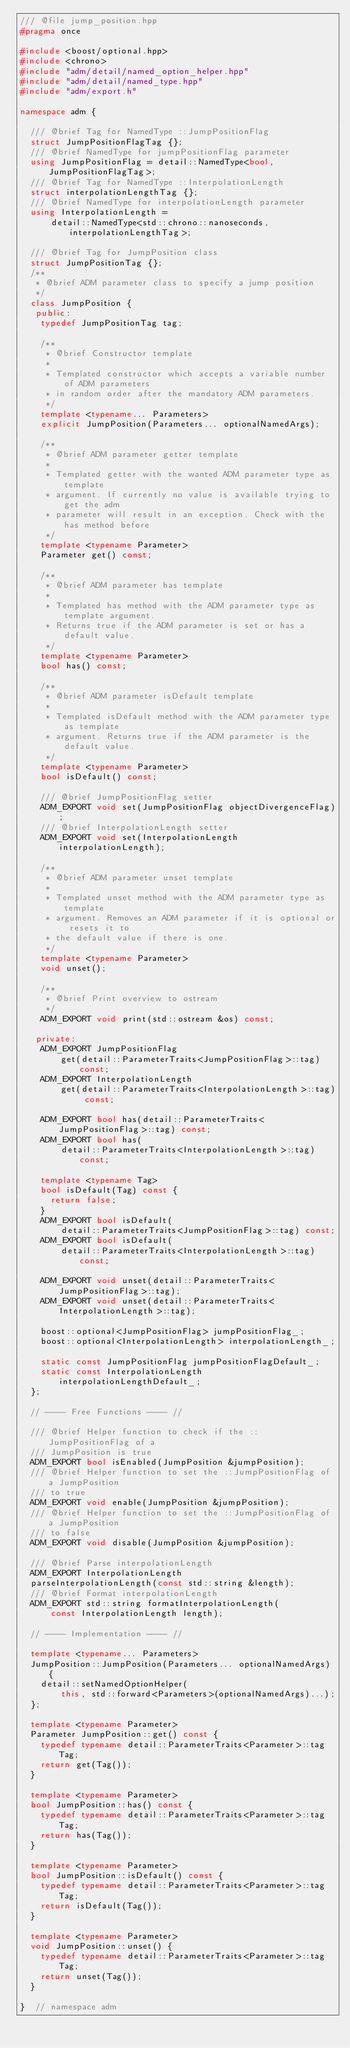Convert code to text. <code><loc_0><loc_0><loc_500><loc_500><_C++_>/// @file jump_position.hpp
#pragma once

#include <boost/optional.hpp>
#include <chrono>
#include "adm/detail/named_option_helper.hpp"
#include "adm/detail/named_type.hpp"
#include "adm/export.h"

namespace adm {

  /// @brief Tag for NamedType ::JumpPositionFlag
  struct JumpPositionFlagTag {};
  /// @brief NamedType for jumpPositionFlag parameter
  using JumpPositionFlag = detail::NamedType<bool, JumpPositionFlagTag>;
  /// @brief Tag for NamedType ::InterpolationLength
  struct interpolationLengthTag {};
  /// @brief NamedType for interpolationLength parameter
  using InterpolationLength =
      detail::NamedType<std::chrono::nanoseconds, interpolationLengthTag>;

  /// @brief Tag for JumpPosition class
  struct JumpPositionTag {};
  /**
   * @brief ADM parameter class to specify a jump position
   */
  class JumpPosition {
   public:
    typedef JumpPositionTag tag;

    /**
     * @brief Constructor template
     *
     * Templated constructor which accepts a variable number of ADM parameters
     * in random order after the mandatory ADM parameters.
     */
    template <typename... Parameters>
    explicit JumpPosition(Parameters... optionalNamedArgs);

    /**
     * @brief ADM parameter getter template
     *
     * Templated getter with the wanted ADM parameter type as template
     * argument. If currently no value is available trying to get the adm
     * parameter will result in an exception. Check with the has method before
     */
    template <typename Parameter>
    Parameter get() const;

    /**
     * @brief ADM parameter has template
     *
     * Templated has method with the ADM parameter type as template argument.
     * Returns true if the ADM parameter is set or has a default value.
     */
    template <typename Parameter>
    bool has() const;

    /**
     * @brief ADM parameter isDefault template
     *
     * Templated isDefault method with the ADM parameter type as template
     * argument. Returns true if the ADM parameter is the default value.
     */
    template <typename Parameter>
    bool isDefault() const;

    /// @brief JumpPositionFlag setter
    ADM_EXPORT void set(JumpPositionFlag objectDivergenceFlag);
    /// @brief InterpolationLength setter
    ADM_EXPORT void set(InterpolationLength interpolationLength);

    /**
     * @brief ADM parameter unset template
     *
     * Templated unset method with the ADM parameter type as template
     * argument. Removes an ADM parameter if it is optional or resets it to
     * the default value if there is one.
     */
    template <typename Parameter>
    void unset();

    /**
     * @brief Print overview to ostream
     */
    ADM_EXPORT void print(std::ostream &os) const;

   private:
    ADM_EXPORT JumpPositionFlag
        get(detail::ParameterTraits<JumpPositionFlag>::tag) const;
    ADM_EXPORT InterpolationLength
        get(detail::ParameterTraits<InterpolationLength>::tag) const;

    ADM_EXPORT bool has(detail::ParameterTraits<JumpPositionFlag>::tag) const;
    ADM_EXPORT bool has(
        detail::ParameterTraits<InterpolationLength>::tag) const;

    template <typename Tag>
    bool isDefault(Tag) const {
      return false;
    }
    ADM_EXPORT bool isDefault(
        detail::ParameterTraits<JumpPositionFlag>::tag) const;
    ADM_EXPORT bool isDefault(
        detail::ParameterTraits<InterpolationLength>::tag) const;

    ADM_EXPORT void unset(detail::ParameterTraits<JumpPositionFlag>::tag);
    ADM_EXPORT void unset(detail::ParameterTraits<InterpolationLength>::tag);

    boost::optional<JumpPositionFlag> jumpPositionFlag_;
    boost::optional<InterpolationLength> interpolationLength_;

    static const JumpPositionFlag jumpPositionFlagDefault_;
    static const InterpolationLength interpolationLengthDefault_;
  };

  // ---- Free Functions ---- //

  /// @brief Helper function to check if the ::JumpPositionFlag of a
  /// JumpPosition is true
  ADM_EXPORT bool isEnabled(JumpPosition &jumpPosition);
  /// @brief Helper function to set the ::JumpPositionFlag of a JumpPosition
  /// to true
  ADM_EXPORT void enable(JumpPosition &jumpPosition);
  /// @brief Helper function to set the ::JumpPositionFlag of a JumpPosition
  /// to false
  ADM_EXPORT void disable(JumpPosition &jumpPosition);

  /// @brief Parse interpolationLength
  ADM_EXPORT InterpolationLength
  parseInterpolationLength(const std::string &length);
  /// @brief Format interpolationLength
  ADM_EXPORT std::string formatInterpolationLength(
      const InterpolationLength length);

  // ---- Implementation ---- //

  template <typename... Parameters>
  JumpPosition::JumpPosition(Parameters... optionalNamedArgs) {
    detail::setNamedOptionHelper(
        this, std::forward<Parameters>(optionalNamedArgs)...);
  };

  template <typename Parameter>
  Parameter JumpPosition::get() const {
    typedef typename detail::ParameterTraits<Parameter>::tag Tag;
    return get(Tag());
  }

  template <typename Parameter>
  bool JumpPosition::has() const {
    typedef typename detail::ParameterTraits<Parameter>::tag Tag;
    return has(Tag());
  }

  template <typename Parameter>
  bool JumpPosition::isDefault() const {
    typedef typename detail::ParameterTraits<Parameter>::tag Tag;
    return isDefault(Tag());
  }

  template <typename Parameter>
  void JumpPosition::unset() {
    typedef typename detail::ParameterTraits<Parameter>::tag Tag;
    return unset(Tag());
  }

}  // namespace adm
</code> 